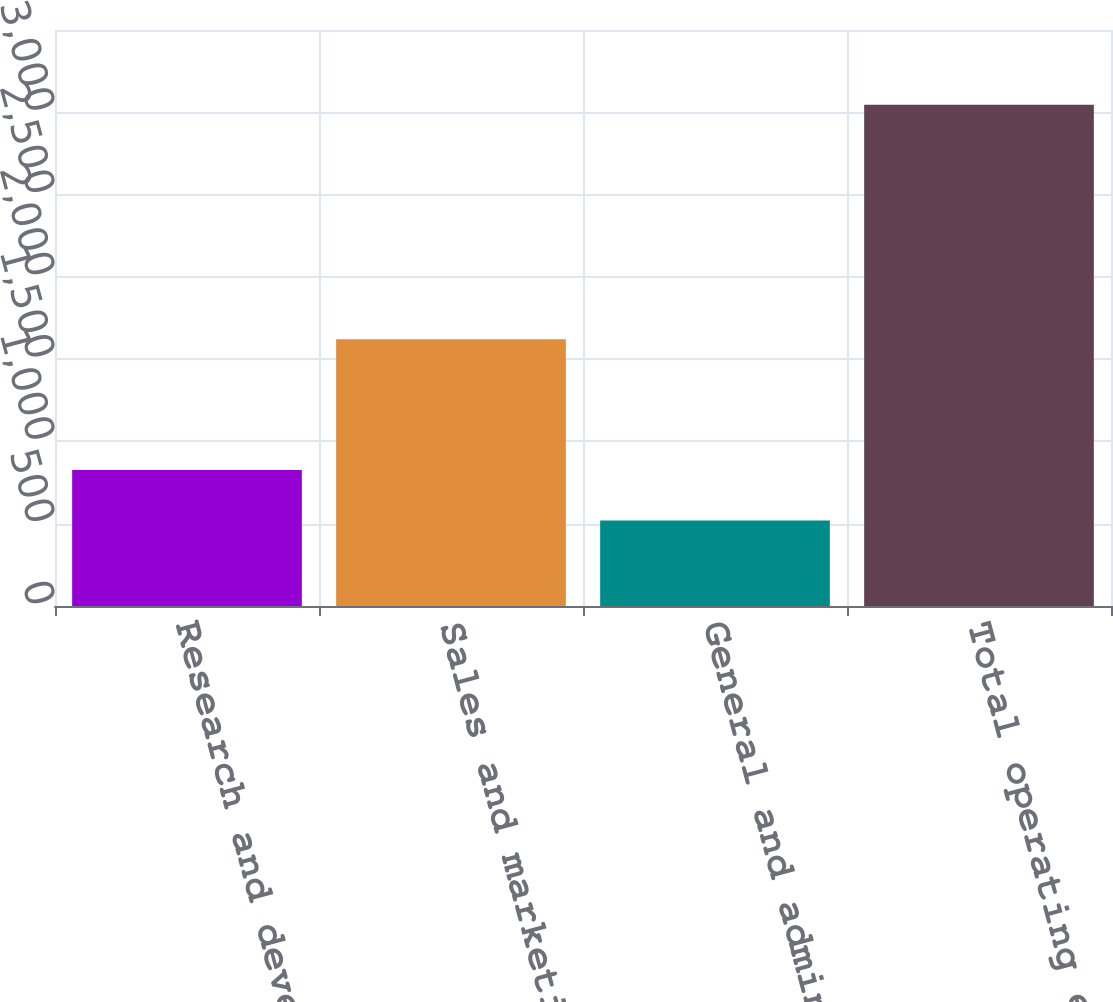<chart> <loc_0><loc_0><loc_500><loc_500><bar_chart><fcel>Research and development<fcel>Sales and marketing<fcel>General and administrative<fcel>Total operating expenses<nl><fcel>826.6<fcel>1620.5<fcel>520.1<fcel>3046<nl></chart> 